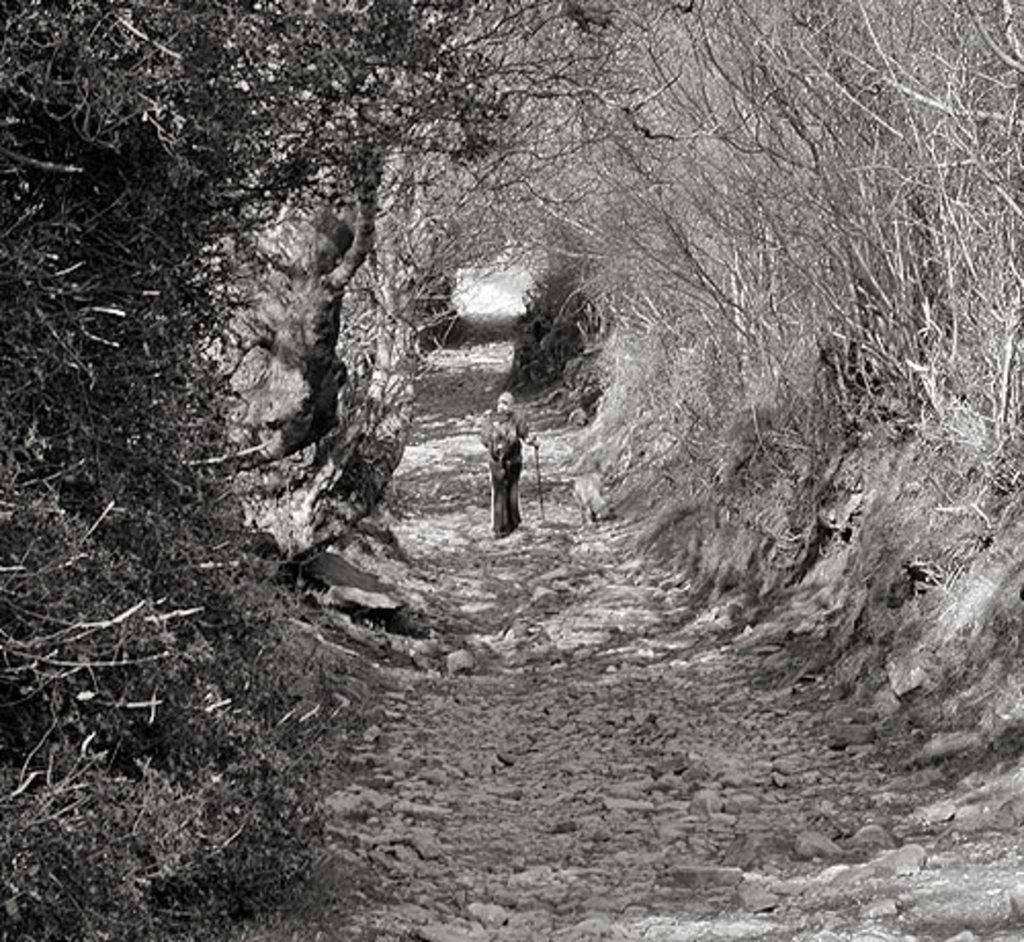What is the color scheme of the image? The image is black and white. What is the person in the image doing? The person is standing on the ground and holding walking sticks in their hands. What can be seen in the background of the image? There are trees in the background of the image. Where is the kettle located in the image? There is no kettle present in the image. What type of throne is the person sitting on in the image? There is no throne in the image; the person is standing on the ground. 